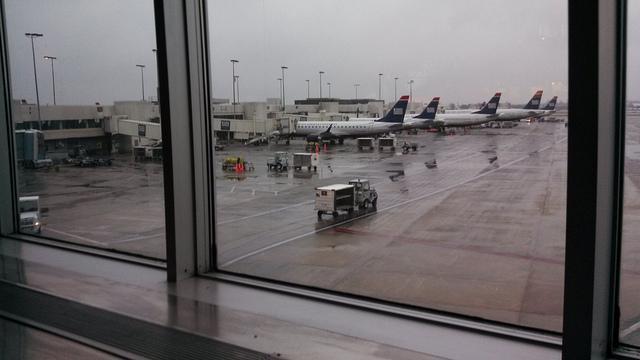What would be the most likely cause of a travel delay for this airport?
Choose the right answer from the provided options to respond to the question.
Options: Rain, snow, wind, clouds. Clouds. 